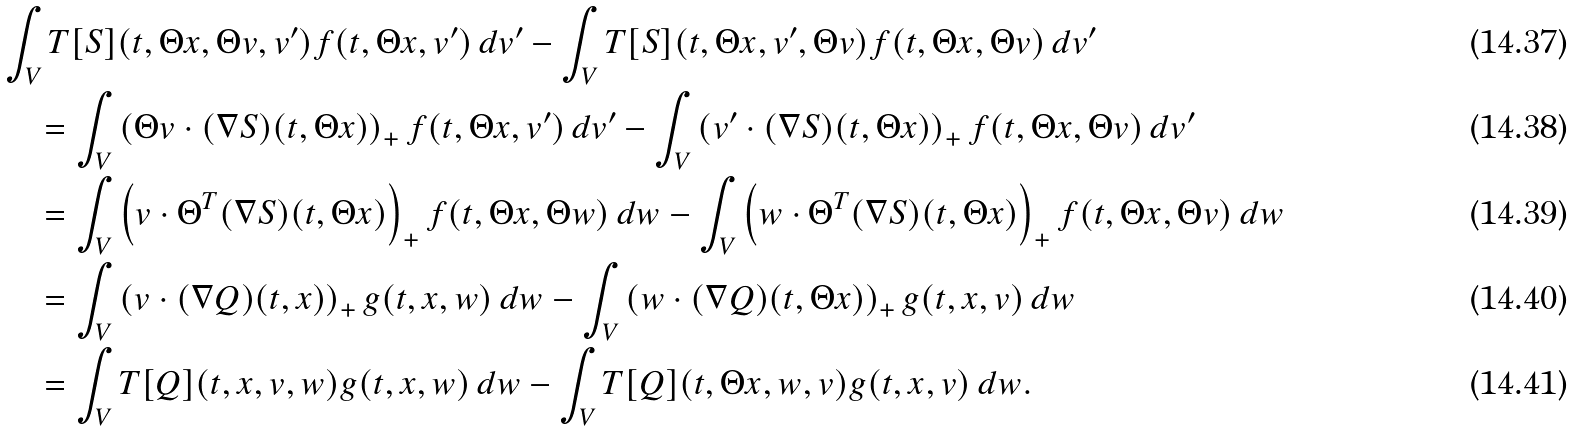Convert formula to latex. <formula><loc_0><loc_0><loc_500><loc_500>& \int _ { V } T [ S ] ( t , \Theta x , \Theta v , v ^ { \prime } ) f ( t , \Theta x , v ^ { \prime } ) \, d v ^ { \prime } - \int _ { V } T [ S ] ( t , \Theta x , v ^ { \prime } , \Theta v ) f ( t , \Theta x , \Theta v ) \, d v ^ { \prime } \\ & \quad = \int _ { V } \left ( \Theta v \cdot ( \nabla S ) ( t , \Theta x ) \right ) _ { + } f ( t , \Theta x , v ^ { \prime } ) \, d v ^ { \prime } - \int _ { V } \left ( v ^ { \prime } \cdot ( \nabla S ) ( t , \Theta x ) \right ) _ { + } f ( t , \Theta x , \Theta v ) \, d v ^ { \prime } \\ & \quad = \int _ { V } \left ( v \cdot \Theta ^ { T } ( \nabla S ) ( t , \Theta x ) \right ) _ { + } f ( t , \Theta x , \Theta w ) \, d w - \int _ { V } \left ( w \cdot \Theta ^ { T } ( \nabla S ) ( t , \Theta x ) \right ) _ { + } f ( t , \Theta x , \Theta v ) \, d w \\ & \quad = \int _ { V } \left ( v \cdot ( \nabla Q ) ( t , x ) \right ) _ { + } g ( t , x , w ) \, d w - \int _ { V } \left ( w \cdot ( \nabla Q ) ( t , \Theta x ) \right ) _ { + } g ( t , x , v ) \, d w \\ & \quad = \int _ { V } T [ Q ] ( t , x , v , w ) g ( t , x , w ) \, d w - \int _ { V } T [ Q ] ( t , \Theta x , w , v ) g ( t , x , v ) \, d w .</formula> 